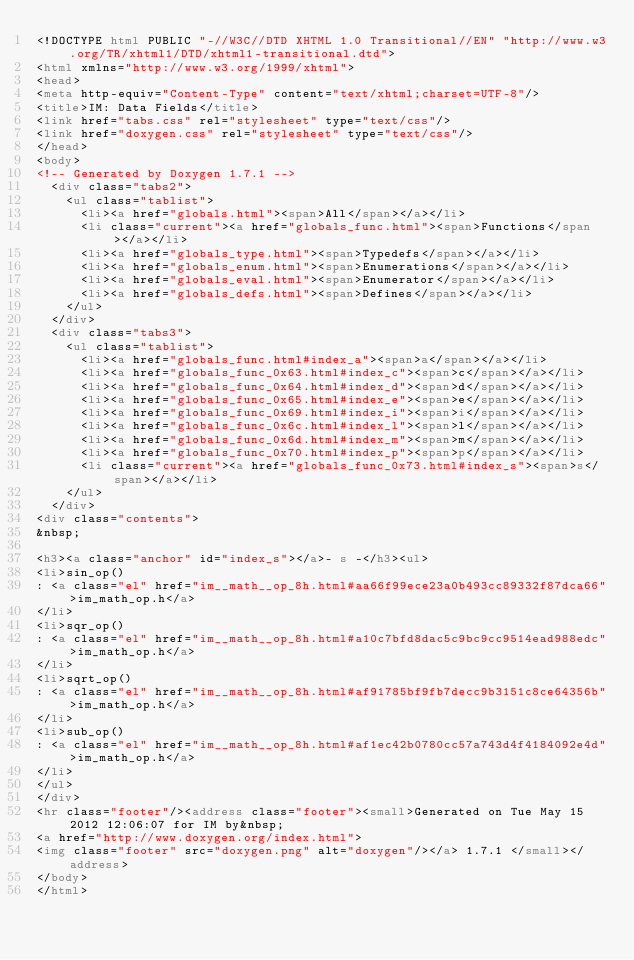Convert code to text. <code><loc_0><loc_0><loc_500><loc_500><_HTML_><!DOCTYPE html PUBLIC "-//W3C//DTD XHTML 1.0 Transitional//EN" "http://www.w3.org/TR/xhtml1/DTD/xhtml1-transitional.dtd">
<html xmlns="http://www.w3.org/1999/xhtml">
<head>
<meta http-equiv="Content-Type" content="text/xhtml;charset=UTF-8"/>
<title>IM: Data Fields</title>
<link href="tabs.css" rel="stylesheet" type="text/css"/>
<link href="doxygen.css" rel="stylesheet" type="text/css"/>
</head>
<body>
<!-- Generated by Doxygen 1.7.1 -->
  <div class="tabs2">
    <ul class="tablist">
      <li><a href="globals.html"><span>All</span></a></li>
      <li class="current"><a href="globals_func.html"><span>Functions</span></a></li>
      <li><a href="globals_type.html"><span>Typedefs</span></a></li>
      <li><a href="globals_enum.html"><span>Enumerations</span></a></li>
      <li><a href="globals_eval.html"><span>Enumerator</span></a></li>
      <li><a href="globals_defs.html"><span>Defines</span></a></li>
    </ul>
  </div>
  <div class="tabs3">
    <ul class="tablist">
      <li><a href="globals_func.html#index_a"><span>a</span></a></li>
      <li><a href="globals_func_0x63.html#index_c"><span>c</span></a></li>
      <li><a href="globals_func_0x64.html#index_d"><span>d</span></a></li>
      <li><a href="globals_func_0x65.html#index_e"><span>e</span></a></li>
      <li><a href="globals_func_0x69.html#index_i"><span>i</span></a></li>
      <li><a href="globals_func_0x6c.html#index_l"><span>l</span></a></li>
      <li><a href="globals_func_0x6d.html#index_m"><span>m</span></a></li>
      <li><a href="globals_func_0x70.html#index_p"><span>p</span></a></li>
      <li class="current"><a href="globals_func_0x73.html#index_s"><span>s</span></a></li>
    </ul>
  </div>
<div class="contents">
&nbsp;

<h3><a class="anchor" id="index_s"></a>- s -</h3><ul>
<li>sin_op()
: <a class="el" href="im__math__op_8h.html#aa66f99ece23a0b493cc89332f87dca66">im_math_op.h</a>
</li>
<li>sqr_op()
: <a class="el" href="im__math__op_8h.html#a10c7bfd8dac5c9bc9cc9514ead988edc">im_math_op.h</a>
</li>
<li>sqrt_op()
: <a class="el" href="im__math__op_8h.html#af91785bf9fb7decc9b3151c8ce64356b">im_math_op.h</a>
</li>
<li>sub_op()
: <a class="el" href="im__math__op_8h.html#af1ec42b0780cc57a743d4f4184092e4d">im_math_op.h</a>
</li>
</ul>
</div>
<hr class="footer"/><address class="footer"><small>Generated on Tue May 15 2012 12:06:07 for IM by&nbsp;
<a href="http://www.doxygen.org/index.html">
<img class="footer" src="doxygen.png" alt="doxygen"/></a> 1.7.1 </small></address>
</body>
</html>
</code> 